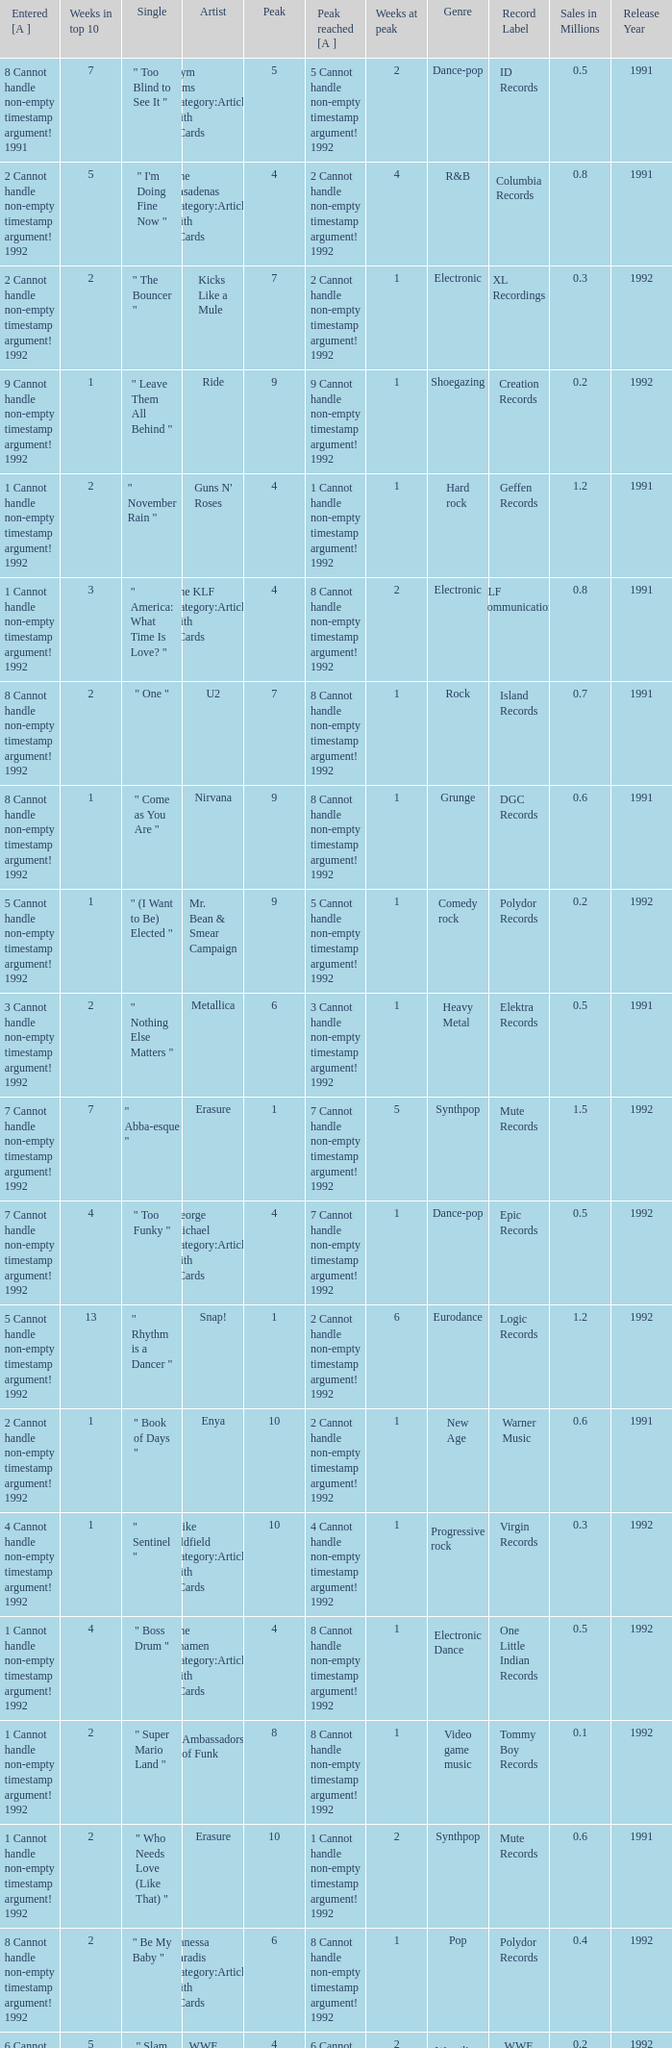What was the peak reached for a single with 4 weeks in the top 10 and entered in 7 cannot handle non-empty timestamp argument! 1992? 7 Cannot handle non-empty timestamp argument! 1992. 